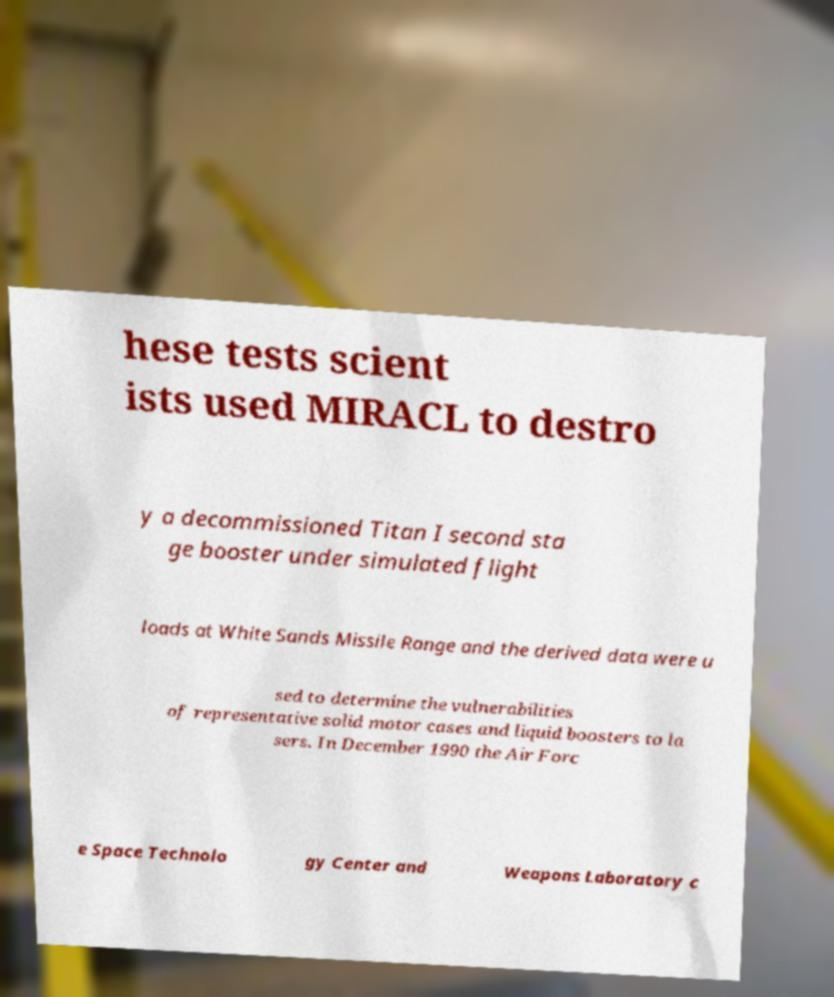For documentation purposes, I need the text within this image transcribed. Could you provide that? hese tests scient ists used MIRACL to destro y a decommissioned Titan I second sta ge booster under simulated flight loads at White Sands Missile Range and the derived data were u sed to determine the vulnerabilities of representative solid motor cases and liquid boosters to la sers. In December 1990 the Air Forc e Space Technolo gy Center and Weapons Laboratory c 